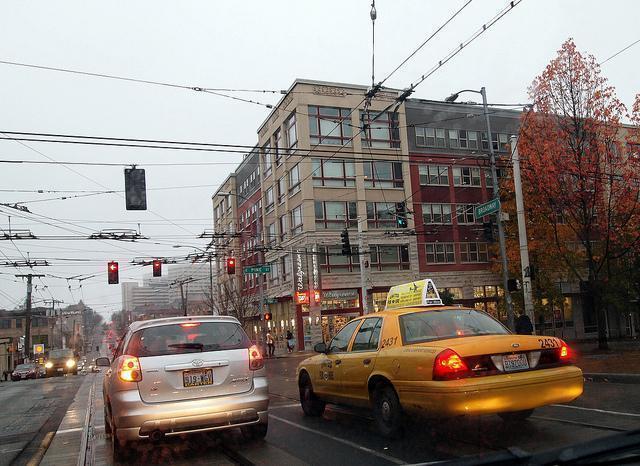Which car is stopped before white line?
Choose the right answer from the provided options to respond to the question.
Options: Both, toyota, neither, cab. Cab. 